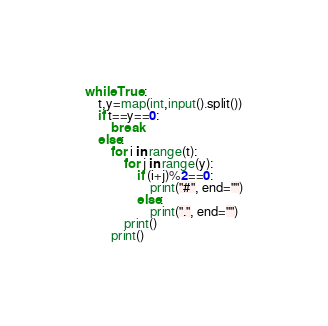Convert code to text. <code><loc_0><loc_0><loc_500><loc_500><_Python_>while True:
    t,y=map(int,input().split())
    if t==y==0:
        break
    else:
        for i in range(t):
            for j in range(y):
                if (i+j)%2==0:
                    print("#", end="")
                else:
                    print(".", end="")
            print()
        print()
</code> 